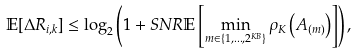Convert formula to latex. <formula><loc_0><loc_0><loc_500><loc_500>\mathbb { E } [ \Delta R _ { i , k } ] \leq \log _ { 2 } \left ( 1 + S N R \mathbb { E } \left [ \min _ { m \in \{ 1 , \dots , 2 ^ { K B } \} } \rho _ { K } \left ( A _ { \left ( m \right ) } \right ) \right ] \right ) ,</formula> 